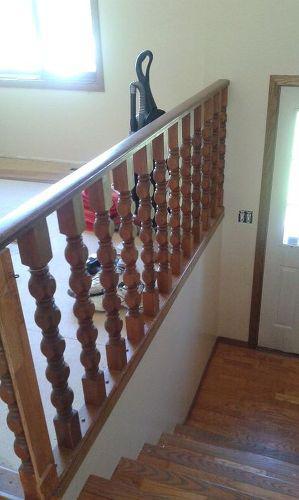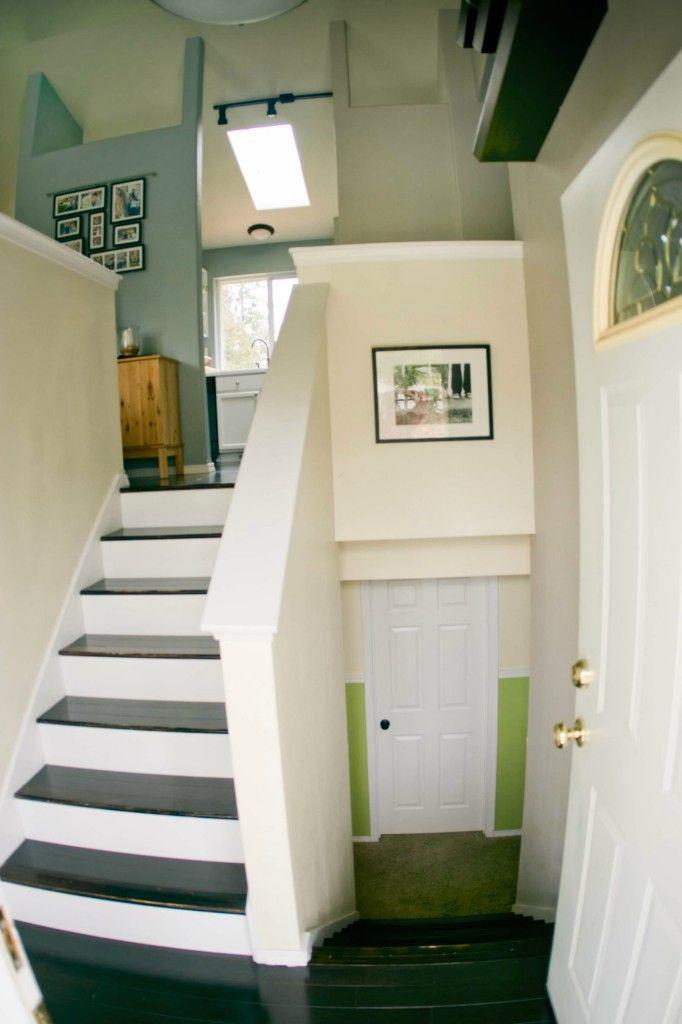The first image is the image on the left, the second image is the image on the right. For the images displayed, is the sentence "An image shows a view down a staircase that leads to a door shape, and a flat ledge is at the left instead of a flight of stairs." factually correct? Answer yes or no. Yes. The first image is the image on the left, the second image is the image on the right. Given the left and right images, does the statement "IN at least one image there is at least one sofa chair to the side of a staircase on the first floor." hold true? Answer yes or no. No. 